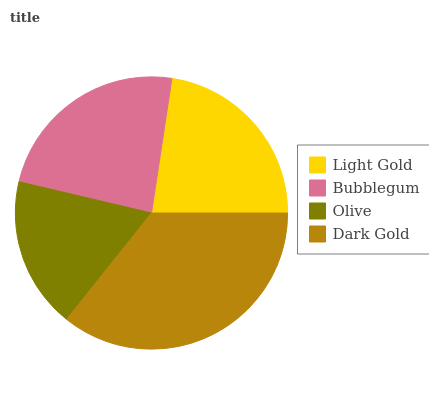Is Olive the minimum?
Answer yes or no. Yes. Is Dark Gold the maximum?
Answer yes or no. Yes. Is Bubblegum the minimum?
Answer yes or no. No. Is Bubblegum the maximum?
Answer yes or no. No. Is Bubblegum greater than Light Gold?
Answer yes or no. Yes. Is Light Gold less than Bubblegum?
Answer yes or no. Yes. Is Light Gold greater than Bubblegum?
Answer yes or no. No. Is Bubblegum less than Light Gold?
Answer yes or no. No. Is Bubblegum the high median?
Answer yes or no. Yes. Is Light Gold the low median?
Answer yes or no. Yes. Is Light Gold the high median?
Answer yes or no. No. Is Dark Gold the low median?
Answer yes or no. No. 